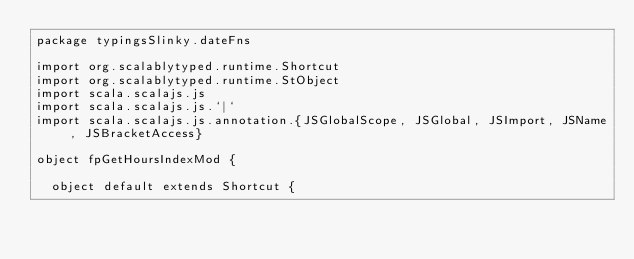Convert code to text. <code><loc_0><loc_0><loc_500><loc_500><_Scala_>package typingsSlinky.dateFns

import org.scalablytyped.runtime.Shortcut
import org.scalablytyped.runtime.StObject
import scala.scalajs.js
import scala.scalajs.js.`|`
import scala.scalajs.js.annotation.{JSGlobalScope, JSGlobal, JSImport, JSName, JSBracketAccess}

object fpGetHoursIndexMod {
  
  object default extends Shortcut {
    </code> 